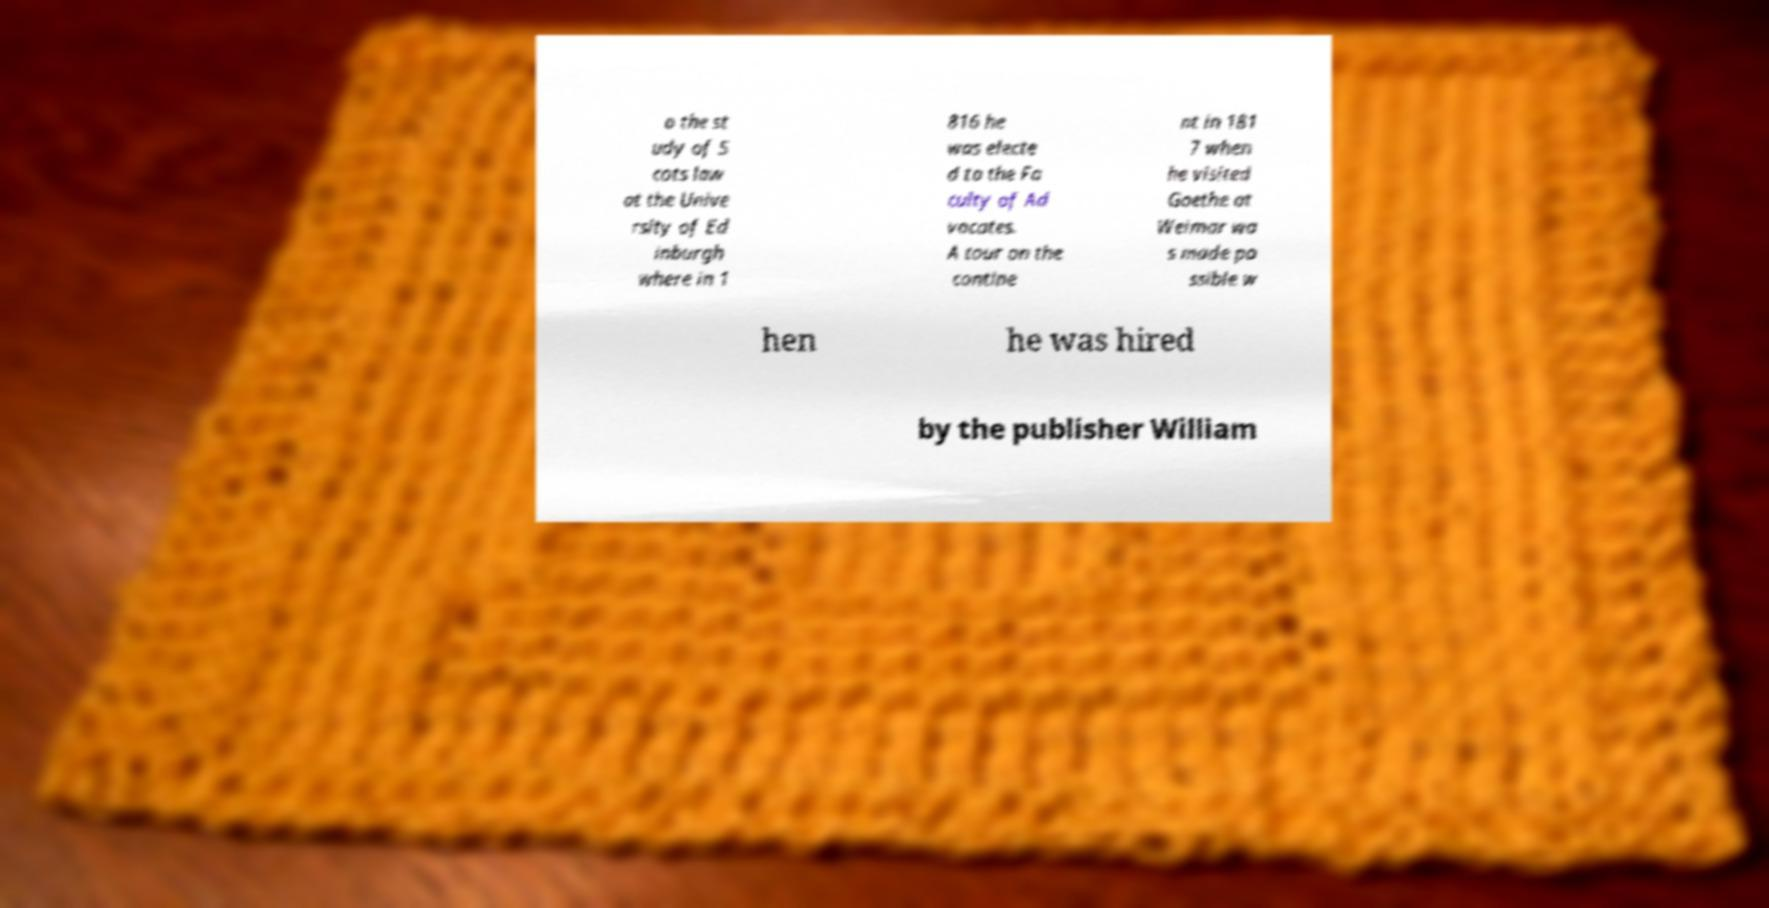Can you accurately transcribe the text from the provided image for me? o the st udy of S cots law at the Unive rsity of Ed inburgh where in 1 816 he was electe d to the Fa culty of Ad vocates. A tour on the contine nt in 181 7 when he visited Goethe at Weimar wa s made po ssible w hen he was hired by the publisher William 